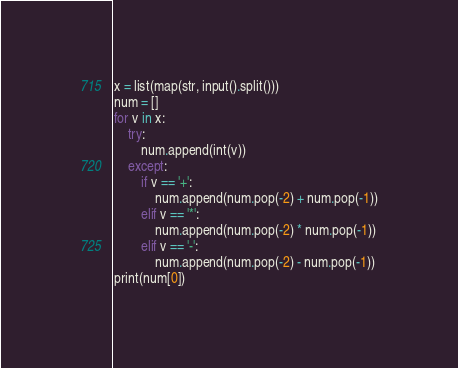Convert code to text. <code><loc_0><loc_0><loc_500><loc_500><_Python_>x = list(map(str, input().split()))
num = []
for v in x:
    try:
        num.append(int(v))
    except:
        if v == '+':
            num.append(num.pop(-2) + num.pop(-1))
        elif v == '*':
            num.append(num.pop(-2) * num.pop(-1))
        elif v == '-':
            num.append(num.pop(-2) - num.pop(-1))
print(num[0])
</code> 